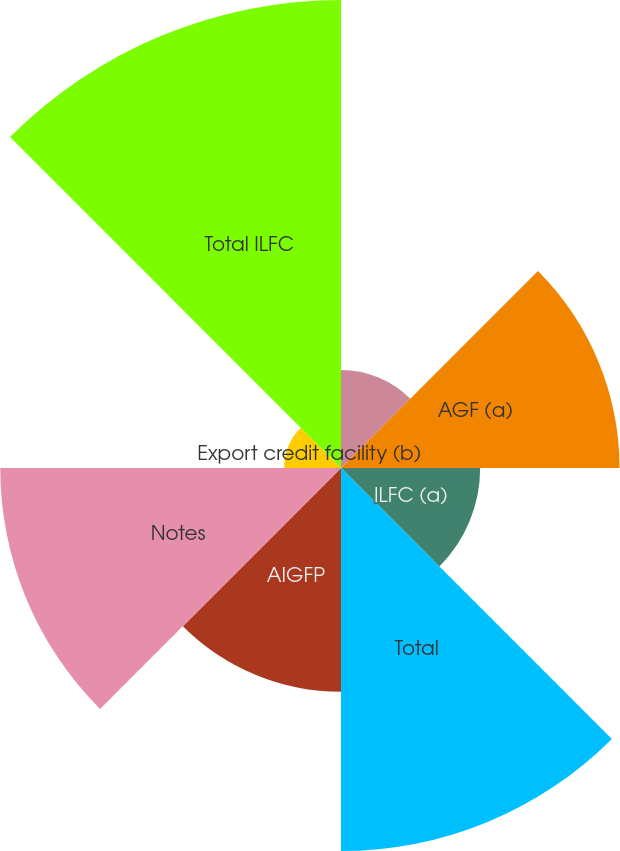Convert chart. <chart><loc_0><loc_0><loc_500><loc_500><pie_chart><fcel>Borrowings under obligations<fcel>AGF (a)<fcel>ILFC (a)<fcel>Total<fcel>AIGFP<fcel>Notes<fcel>Export credit facility (b)<fcel>Total ILFC<nl><fcel>4.93%<fcel>14.01%<fcel>7.0%<fcel>19.27%<fcel>11.25%<fcel>17.14%<fcel>2.86%<fcel>23.54%<nl></chart> 